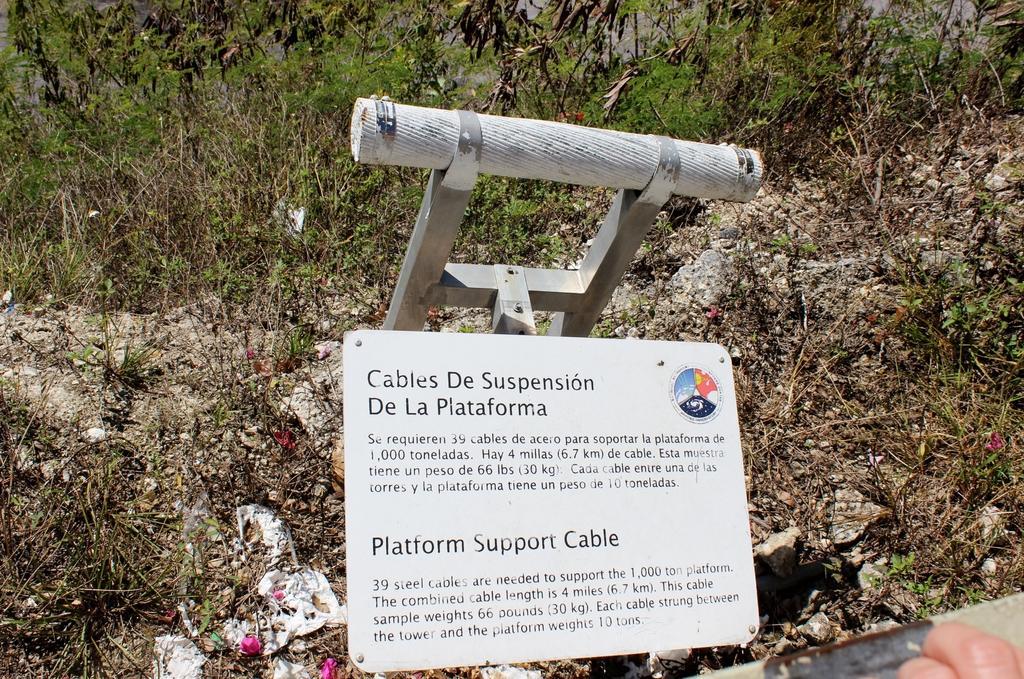Could you give a brief overview of what you see in this image? In this image there is a board, on that board there is some text, in the background there are plants on soil. 